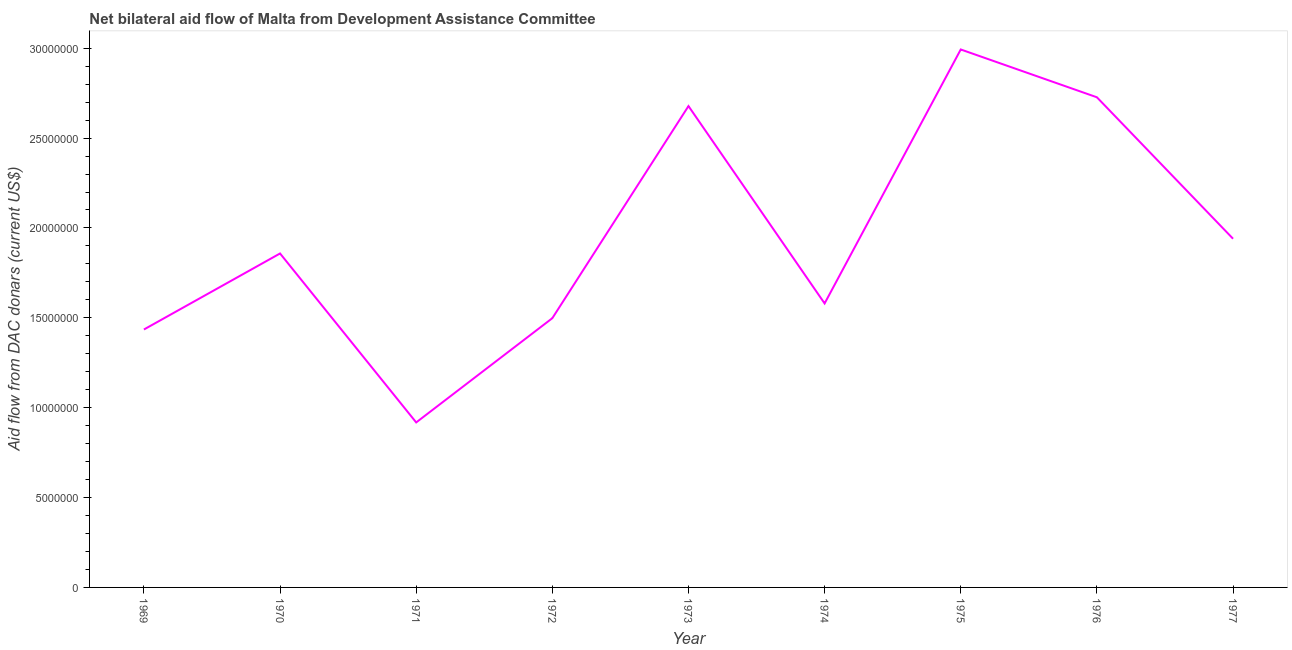What is the net bilateral aid flows from dac donors in 1970?
Give a very brief answer. 1.86e+07. Across all years, what is the maximum net bilateral aid flows from dac donors?
Your answer should be compact. 2.99e+07. Across all years, what is the minimum net bilateral aid flows from dac donors?
Offer a terse response. 9.18e+06. In which year was the net bilateral aid flows from dac donors maximum?
Provide a succinct answer. 1975. In which year was the net bilateral aid flows from dac donors minimum?
Your answer should be very brief. 1971. What is the sum of the net bilateral aid flows from dac donors?
Provide a short and direct response. 1.76e+08. What is the difference between the net bilateral aid flows from dac donors in 1975 and 1976?
Provide a short and direct response. 2.66e+06. What is the average net bilateral aid flows from dac donors per year?
Ensure brevity in your answer.  1.96e+07. What is the median net bilateral aid flows from dac donors?
Your answer should be very brief. 1.86e+07. What is the ratio of the net bilateral aid flows from dac donors in 1973 to that in 1977?
Give a very brief answer. 1.38. Is the net bilateral aid flows from dac donors in 1973 less than that in 1976?
Provide a short and direct response. Yes. Is the difference between the net bilateral aid flows from dac donors in 1970 and 1973 greater than the difference between any two years?
Ensure brevity in your answer.  No. What is the difference between the highest and the second highest net bilateral aid flows from dac donors?
Offer a terse response. 2.66e+06. Is the sum of the net bilateral aid flows from dac donors in 1974 and 1975 greater than the maximum net bilateral aid flows from dac donors across all years?
Offer a terse response. Yes. What is the difference between the highest and the lowest net bilateral aid flows from dac donors?
Your answer should be very brief. 2.08e+07. In how many years, is the net bilateral aid flows from dac donors greater than the average net bilateral aid flows from dac donors taken over all years?
Provide a succinct answer. 3. How many lines are there?
Your answer should be very brief. 1. How many years are there in the graph?
Your answer should be very brief. 9. Are the values on the major ticks of Y-axis written in scientific E-notation?
Make the answer very short. No. What is the title of the graph?
Provide a succinct answer. Net bilateral aid flow of Malta from Development Assistance Committee. What is the label or title of the X-axis?
Ensure brevity in your answer.  Year. What is the label or title of the Y-axis?
Make the answer very short. Aid flow from DAC donars (current US$). What is the Aid flow from DAC donars (current US$) in 1969?
Keep it short and to the point. 1.44e+07. What is the Aid flow from DAC donars (current US$) in 1970?
Your response must be concise. 1.86e+07. What is the Aid flow from DAC donars (current US$) in 1971?
Provide a short and direct response. 9.18e+06. What is the Aid flow from DAC donars (current US$) of 1972?
Your answer should be very brief. 1.50e+07. What is the Aid flow from DAC donars (current US$) in 1973?
Ensure brevity in your answer.  2.68e+07. What is the Aid flow from DAC donars (current US$) in 1974?
Your answer should be compact. 1.58e+07. What is the Aid flow from DAC donars (current US$) of 1975?
Provide a short and direct response. 2.99e+07. What is the Aid flow from DAC donars (current US$) in 1976?
Give a very brief answer. 2.73e+07. What is the Aid flow from DAC donars (current US$) of 1977?
Make the answer very short. 1.94e+07. What is the difference between the Aid flow from DAC donars (current US$) in 1969 and 1970?
Your response must be concise. -4.23e+06. What is the difference between the Aid flow from DAC donars (current US$) in 1969 and 1971?
Give a very brief answer. 5.17e+06. What is the difference between the Aid flow from DAC donars (current US$) in 1969 and 1972?
Your answer should be very brief. -6.30e+05. What is the difference between the Aid flow from DAC donars (current US$) in 1969 and 1973?
Offer a terse response. -1.24e+07. What is the difference between the Aid flow from DAC donars (current US$) in 1969 and 1974?
Keep it short and to the point. -1.45e+06. What is the difference between the Aid flow from DAC donars (current US$) in 1969 and 1975?
Your answer should be very brief. -1.56e+07. What is the difference between the Aid flow from DAC donars (current US$) in 1969 and 1976?
Your answer should be very brief. -1.29e+07. What is the difference between the Aid flow from DAC donars (current US$) in 1969 and 1977?
Provide a short and direct response. -5.05e+06. What is the difference between the Aid flow from DAC donars (current US$) in 1970 and 1971?
Provide a short and direct response. 9.40e+06. What is the difference between the Aid flow from DAC donars (current US$) in 1970 and 1972?
Offer a very short reply. 3.60e+06. What is the difference between the Aid flow from DAC donars (current US$) in 1970 and 1973?
Offer a terse response. -8.20e+06. What is the difference between the Aid flow from DAC donars (current US$) in 1970 and 1974?
Your response must be concise. 2.78e+06. What is the difference between the Aid flow from DAC donars (current US$) in 1970 and 1975?
Ensure brevity in your answer.  -1.14e+07. What is the difference between the Aid flow from DAC donars (current US$) in 1970 and 1976?
Offer a terse response. -8.69e+06. What is the difference between the Aid flow from DAC donars (current US$) in 1970 and 1977?
Provide a short and direct response. -8.20e+05. What is the difference between the Aid flow from DAC donars (current US$) in 1971 and 1972?
Ensure brevity in your answer.  -5.80e+06. What is the difference between the Aid flow from DAC donars (current US$) in 1971 and 1973?
Offer a terse response. -1.76e+07. What is the difference between the Aid flow from DAC donars (current US$) in 1971 and 1974?
Make the answer very short. -6.62e+06. What is the difference between the Aid flow from DAC donars (current US$) in 1971 and 1975?
Provide a succinct answer. -2.08e+07. What is the difference between the Aid flow from DAC donars (current US$) in 1971 and 1976?
Give a very brief answer. -1.81e+07. What is the difference between the Aid flow from DAC donars (current US$) in 1971 and 1977?
Offer a terse response. -1.02e+07. What is the difference between the Aid flow from DAC donars (current US$) in 1972 and 1973?
Offer a terse response. -1.18e+07. What is the difference between the Aid flow from DAC donars (current US$) in 1972 and 1974?
Offer a very short reply. -8.20e+05. What is the difference between the Aid flow from DAC donars (current US$) in 1972 and 1975?
Provide a succinct answer. -1.50e+07. What is the difference between the Aid flow from DAC donars (current US$) in 1972 and 1976?
Provide a short and direct response. -1.23e+07. What is the difference between the Aid flow from DAC donars (current US$) in 1972 and 1977?
Provide a short and direct response. -4.42e+06. What is the difference between the Aid flow from DAC donars (current US$) in 1973 and 1974?
Your answer should be very brief. 1.10e+07. What is the difference between the Aid flow from DAC donars (current US$) in 1973 and 1975?
Your response must be concise. -3.15e+06. What is the difference between the Aid flow from DAC donars (current US$) in 1973 and 1976?
Offer a terse response. -4.90e+05. What is the difference between the Aid flow from DAC donars (current US$) in 1973 and 1977?
Your answer should be very brief. 7.38e+06. What is the difference between the Aid flow from DAC donars (current US$) in 1974 and 1975?
Make the answer very short. -1.41e+07. What is the difference between the Aid flow from DAC donars (current US$) in 1974 and 1976?
Keep it short and to the point. -1.15e+07. What is the difference between the Aid flow from DAC donars (current US$) in 1974 and 1977?
Ensure brevity in your answer.  -3.60e+06. What is the difference between the Aid flow from DAC donars (current US$) in 1975 and 1976?
Offer a terse response. 2.66e+06. What is the difference between the Aid flow from DAC donars (current US$) in 1975 and 1977?
Offer a very short reply. 1.05e+07. What is the difference between the Aid flow from DAC donars (current US$) in 1976 and 1977?
Give a very brief answer. 7.87e+06. What is the ratio of the Aid flow from DAC donars (current US$) in 1969 to that in 1970?
Keep it short and to the point. 0.77. What is the ratio of the Aid flow from DAC donars (current US$) in 1969 to that in 1971?
Keep it short and to the point. 1.56. What is the ratio of the Aid flow from DAC donars (current US$) in 1969 to that in 1972?
Your answer should be very brief. 0.96. What is the ratio of the Aid flow from DAC donars (current US$) in 1969 to that in 1973?
Provide a succinct answer. 0.54. What is the ratio of the Aid flow from DAC donars (current US$) in 1969 to that in 1974?
Your answer should be compact. 0.91. What is the ratio of the Aid flow from DAC donars (current US$) in 1969 to that in 1975?
Your answer should be very brief. 0.48. What is the ratio of the Aid flow from DAC donars (current US$) in 1969 to that in 1976?
Provide a short and direct response. 0.53. What is the ratio of the Aid flow from DAC donars (current US$) in 1969 to that in 1977?
Your answer should be very brief. 0.74. What is the ratio of the Aid flow from DAC donars (current US$) in 1970 to that in 1971?
Give a very brief answer. 2.02. What is the ratio of the Aid flow from DAC donars (current US$) in 1970 to that in 1972?
Your response must be concise. 1.24. What is the ratio of the Aid flow from DAC donars (current US$) in 1970 to that in 1973?
Provide a short and direct response. 0.69. What is the ratio of the Aid flow from DAC donars (current US$) in 1970 to that in 1974?
Your answer should be very brief. 1.18. What is the ratio of the Aid flow from DAC donars (current US$) in 1970 to that in 1975?
Provide a succinct answer. 0.62. What is the ratio of the Aid flow from DAC donars (current US$) in 1970 to that in 1976?
Offer a terse response. 0.68. What is the ratio of the Aid flow from DAC donars (current US$) in 1970 to that in 1977?
Your answer should be very brief. 0.96. What is the ratio of the Aid flow from DAC donars (current US$) in 1971 to that in 1972?
Provide a short and direct response. 0.61. What is the ratio of the Aid flow from DAC donars (current US$) in 1971 to that in 1973?
Provide a short and direct response. 0.34. What is the ratio of the Aid flow from DAC donars (current US$) in 1971 to that in 1974?
Your response must be concise. 0.58. What is the ratio of the Aid flow from DAC donars (current US$) in 1971 to that in 1975?
Provide a short and direct response. 0.31. What is the ratio of the Aid flow from DAC donars (current US$) in 1971 to that in 1976?
Provide a short and direct response. 0.34. What is the ratio of the Aid flow from DAC donars (current US$) in 1971 to that in 1977?
Offer a terse response. 0.47. What is the ratio of the Aid flow from DAC donars (current US$) in 1972 to that in 1973?
Give a very brief answer. 0.56. What is the ratio of the Aid flow from DAC donars (current US$) in 1972 to that in 1974?
Your answer should be compact. 0.95. What is the ratio of the Aid flow from DAC donars (current US$) in 1972 to that in 1975?
Offer a very short reply. 0.5. What is the ratio of the Aid flow from DAC donars (current US$) in 1972 to that in 1976?
Your answer should be very brief. 0.55. What is the ratio of the Aid flow from DAC donars (current US$) in 1972 to that in 1977?
Provide a succinct answer. 0.77. What is the ratio of the Aid flow from DAC donars (current US$) in 1973 to that in 1974?
Provide a succinct answer. 1.7. What is the ratio of the Aid flow from DAC donars (current US$) in 1973 to that in 1975?
Offer a very short reply. 0.9. What is the ratio of the Aid flow from DAC donars (current US$) in 1973 to that in 1977?
Your answer should be very brief. 1.38. What is the ratio of the Aid flow from DAC donars (current US$) in 1974 to that in 1975?
Your answer should be very brief. 0.53. What is the ratio of the Aid flow from DAC donars (current US$) in 1974 to that in 1976?
Ensure brevity in your answer.  0.58. What is the ratio of the Aid flow from DAC donars (current US$) in 1974 to that in 1977?
Offer a very short reply. 0.81. What is the ratio of the Aid flow from DAC donars (current US$) in 1975 to that in 1976?
Give a very brief answer. 1.1. What is the ratio of the Aid flow from DAC donars (current US$) in 1975 to that in 1977?
Offer a very short reply. 1.54. What is the ratio of the Aid flow from DAC donars (current US$) in 1976 to that in 1977?
Provide a short and direct response. 1.41. 